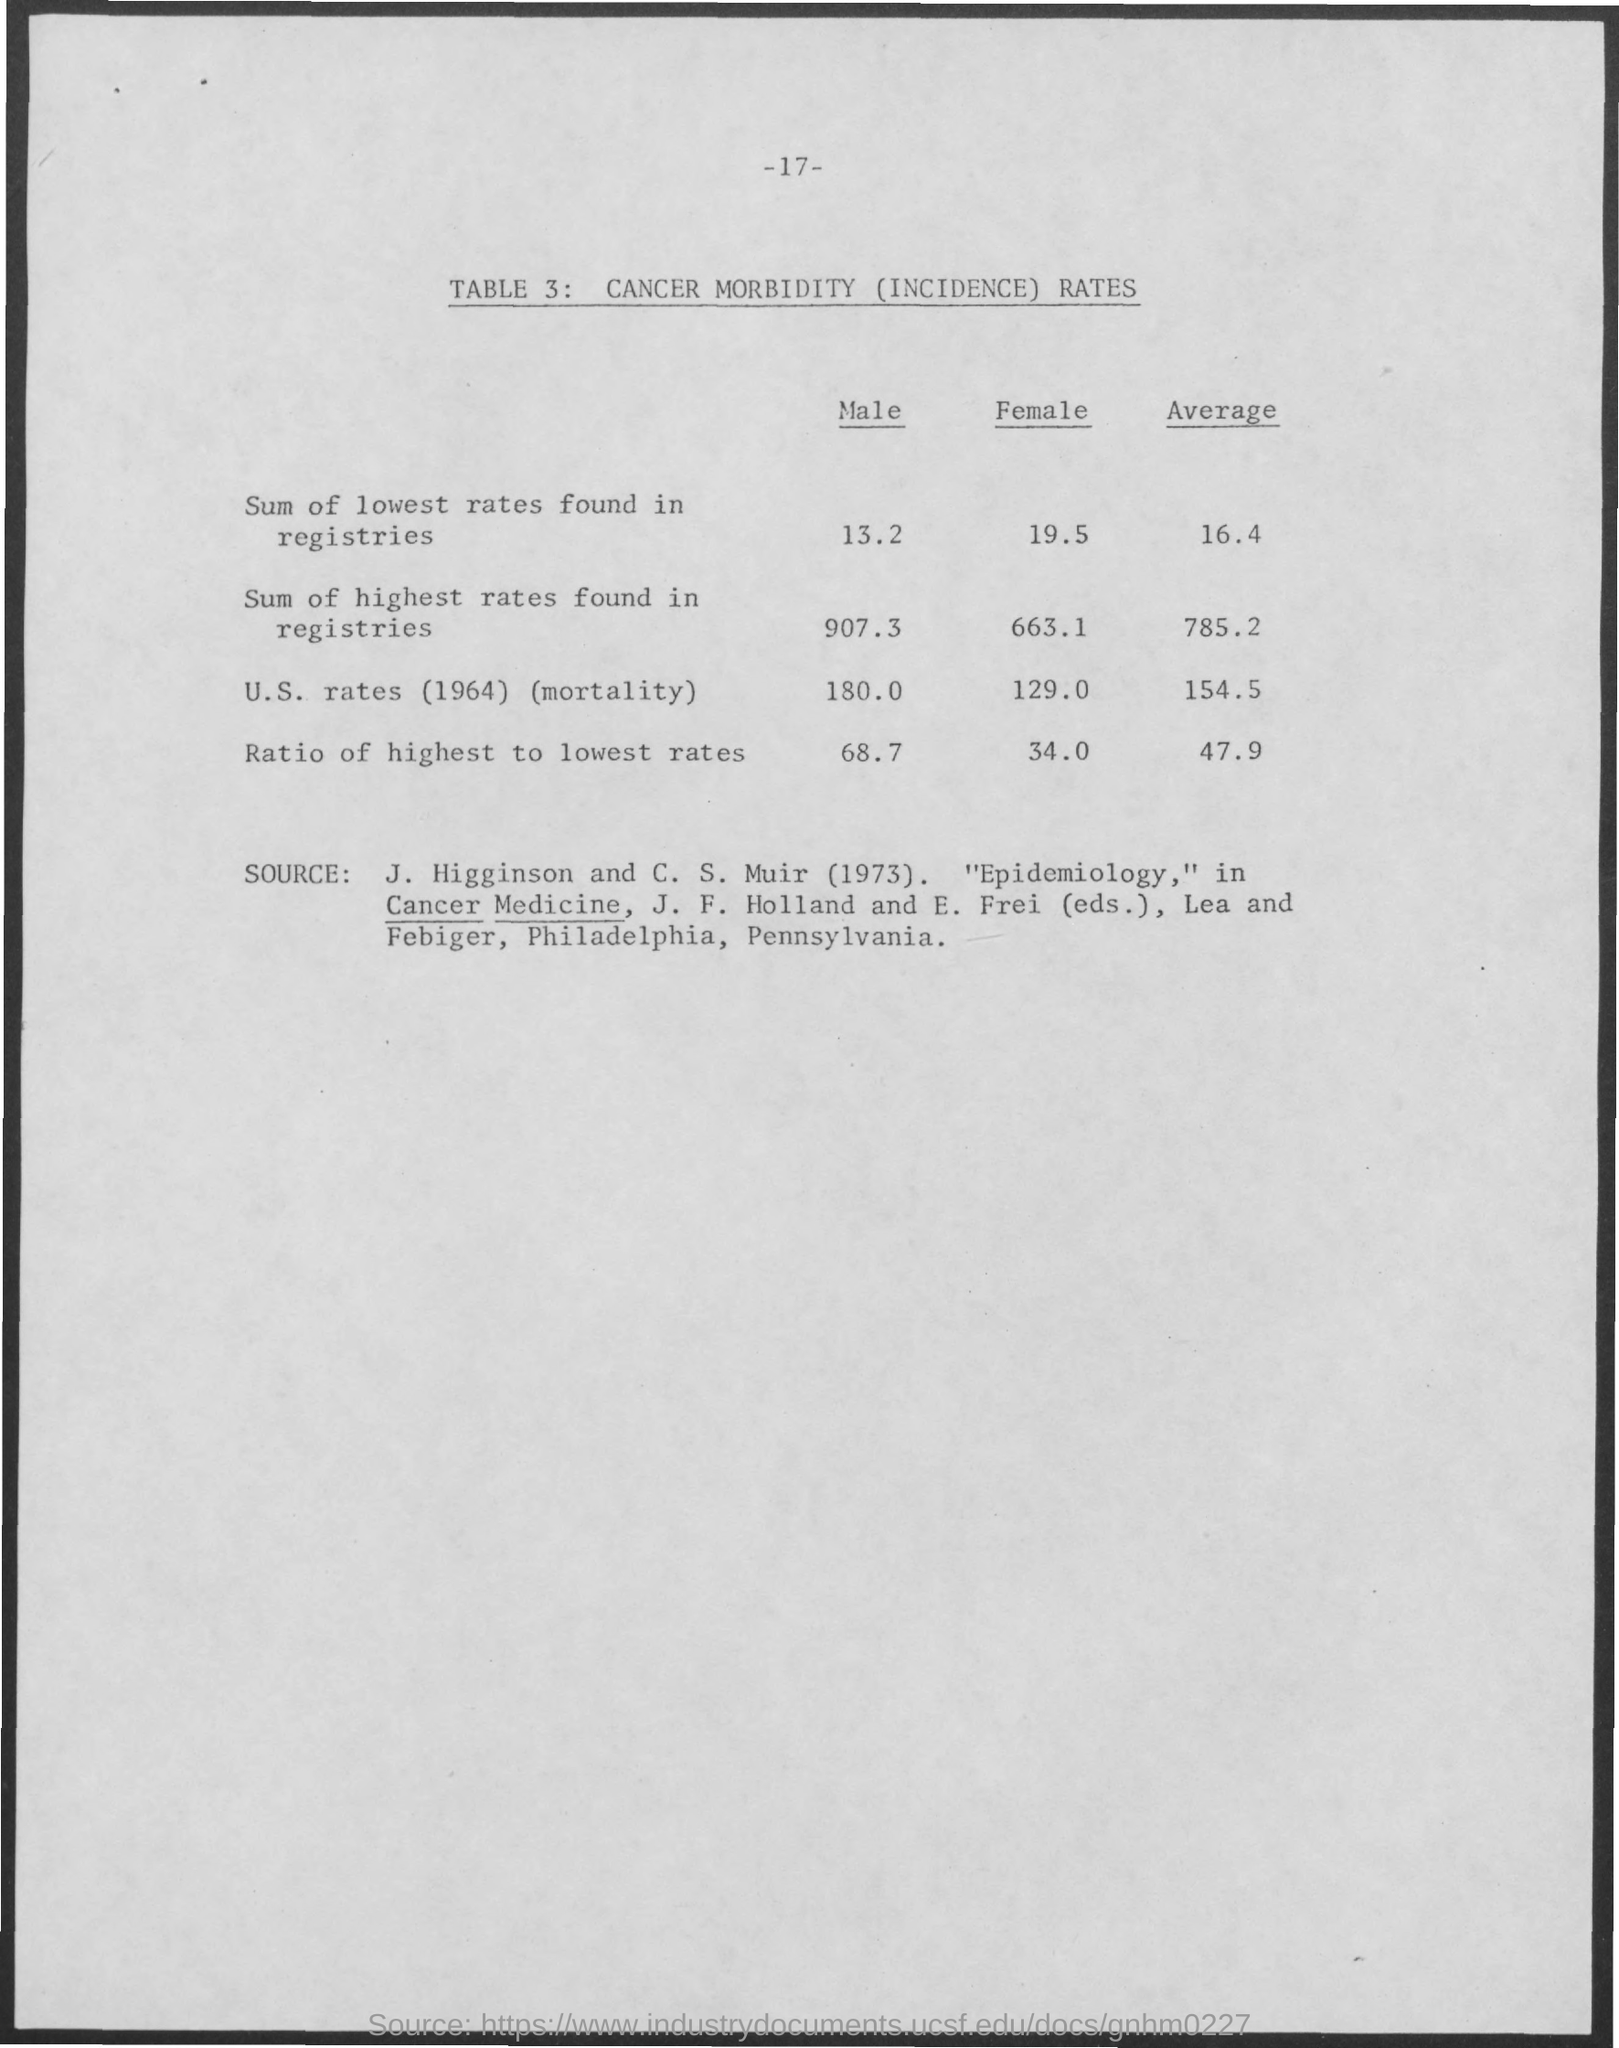What is the Page Number?
Provide a succinct answer. 17. 